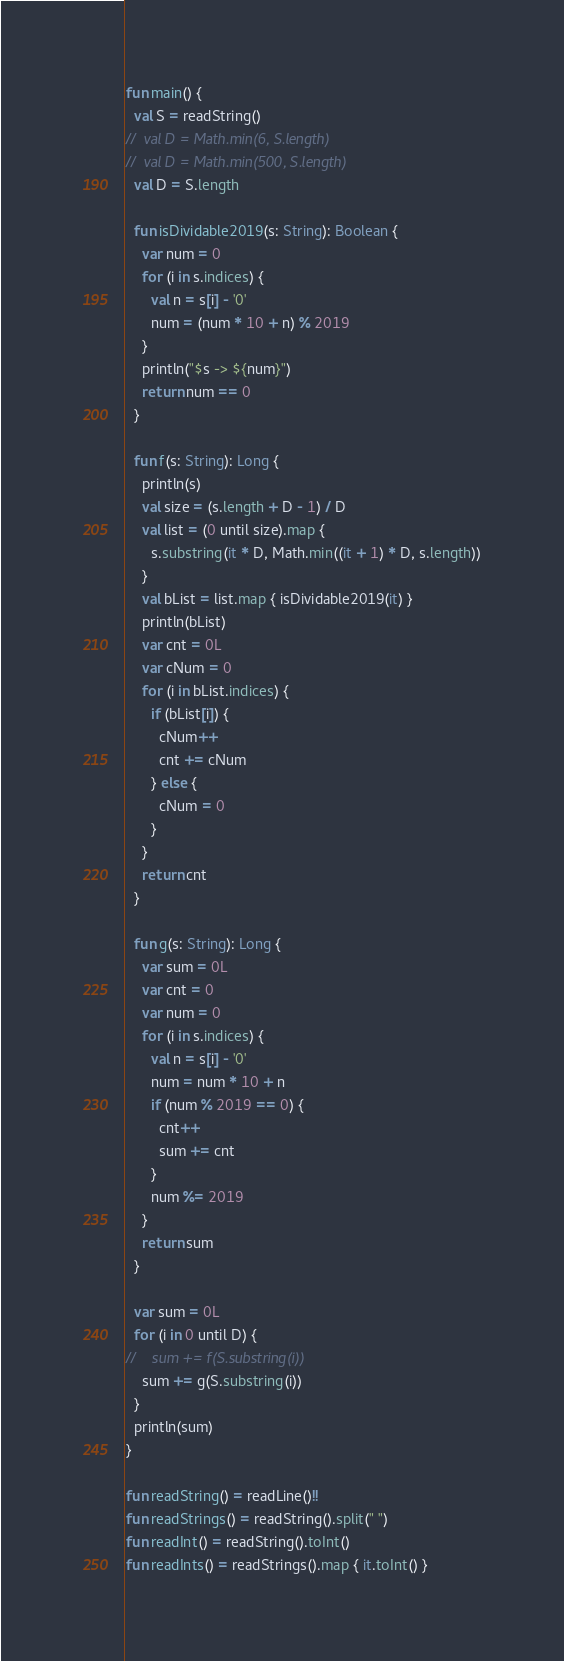Convert code to text. <code><loc_0><loc_0><loc_500><loc_500><_Kotlin_>fun main() {
  val S = readString()
//  val D = Math.min(6, S.length)
//  val D = Math.min(500, S.length)
  val D = S.length

  fun isDividable2019(s: String): Boolean {
    var num = 0
    for (i in s.indices) {
      val n = s[i] - '0'
      num = (num * 10 + n) % 2019
    }
    println("$s -> ${num}")
    return num == 0
  }

  fun f(s: String): Long {
    println(s)
    val size = (s.length + D - 1) / D
    val list = (0 until size).map {
      s.substring(it * D, Math.min((it + 1) * D, s.length))
    }
    val bList = list.map { isDividable2019(it) }
    println(bList)
    var cnt = 0L
    var cNum = 0
    for (i in bList.indices) {
      if (bList[i]) {
        cNum++
        cnt += cNum
      } else {
        cNum = 0
      }
    }
    return cnt
  }

  fun g(s: String): Long {
    var sum = 0L
    var cnt = 0
    var num = 0
    for (i in s.indices) {
      val n = s[i] - '0'
      num = num * 10 + n
      if (num % 2019 == 0) {
        cnt++
        sum += cnt
      }
      num %= 2019
    }
    return sum
  }

  var sum = 0L
  for (i in 0 until D) {
//    sum += f(S.substring(i))
    sum += g(S.substring(i))
  }
  println(sum)
}

fun readString() = readLine()!!
fun readStrings() = readString().split(" ")
fun readInt() = readString().toInt()
fun readInts() = readStrings().map { it.toInt() }
</code> 